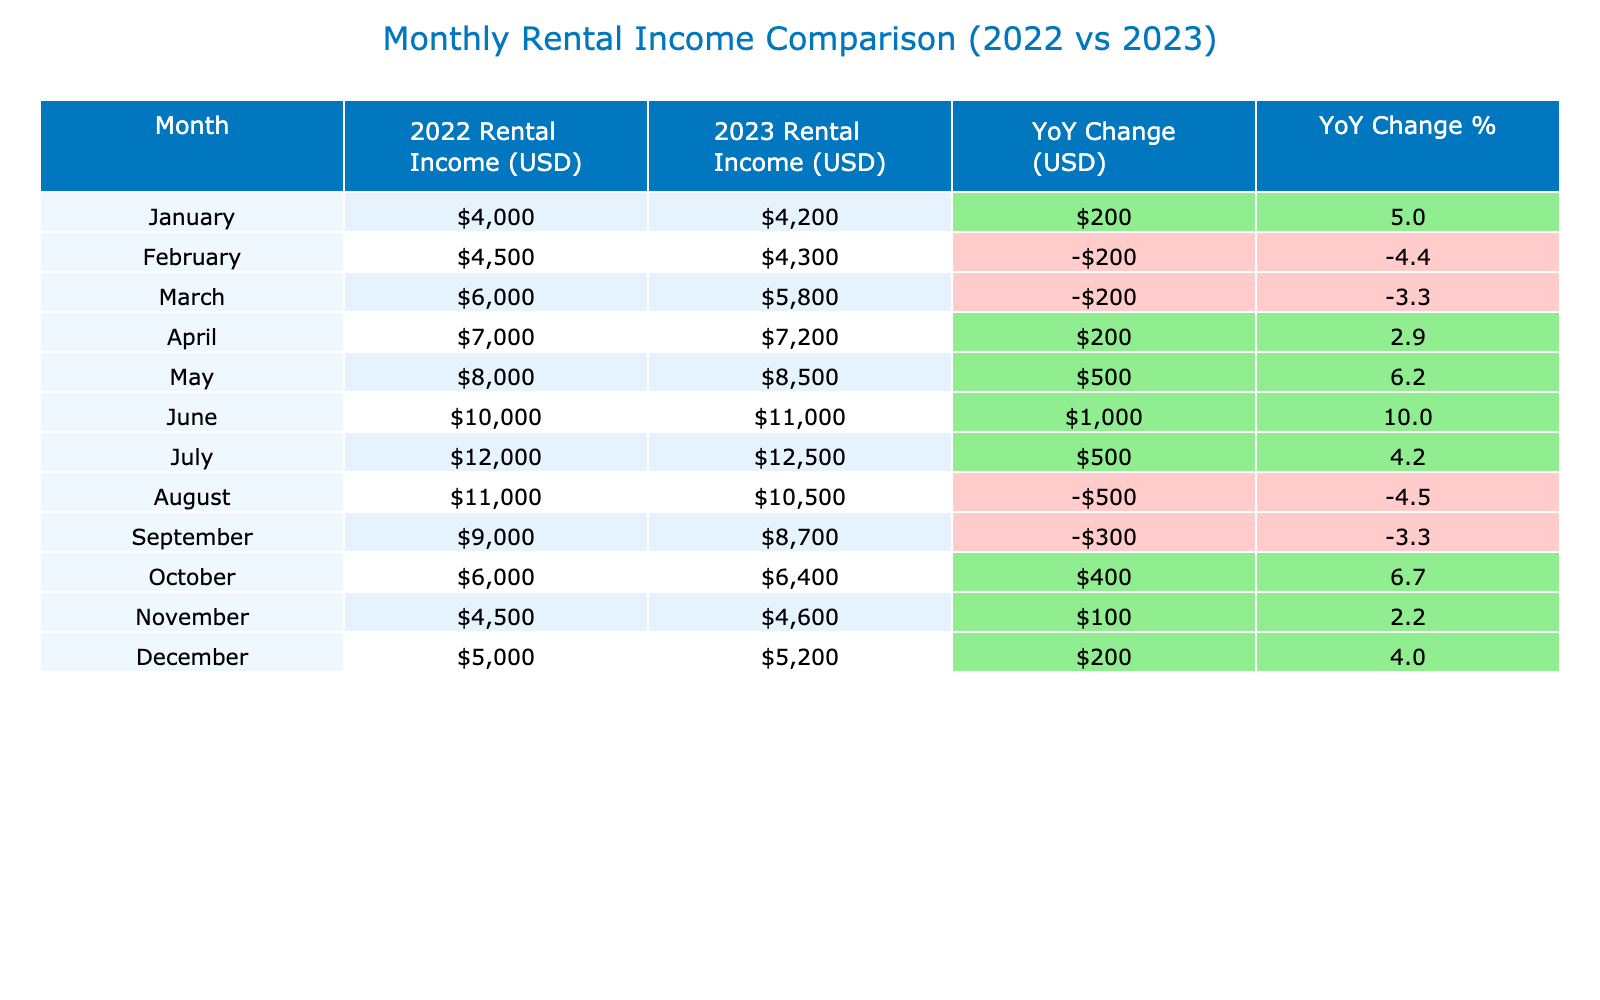What was the rental income for June 2022? By referring to the "2022 Rental Income (USD)" column for June, the value is directly listed as 10000.
Answer: 10000 What is the YoY Change for October? For October, the 2023 Rental Income is 6400 and the 2022 Rental Income is 6000. We calculate the YoY Change as 6400 - 6000 = 400.
Answer: 400 Was the rental income in December 2023 higher than in December 2022? In December 2022, the rental income was 5000, and in December 2023, it was 5200. Since 5200 is greater than 5000, the statement is true.
Answer: Yes What is the total rental income for all months in 2022? To find the total, we sum the 2022 rental income values: 4000 + 4500 + 6000 + 7000 + 8000 + 10000 + 12000 + 11000 + 9000 + 6000 + 4500 + 5000 = 86000.
Answer: 86000 Which month had the highest YoY Change in income? The YoY Change can be calculated for each month, and by examining them, we find that June had the highest YoY Change of 1000.
Answer: June What was the average rental income for the year 2023? The rental incomes for 2023 are: 4200, 4300, 5800, 7200, 8500, 11000, 12500, 10500, 8700, 6400, 4600, 5200. Adding these values gives a total of 69700, and dividing by 12 (the number of months) yields an average of approximately 5816.7.
Answer: 5816.7 Was there a decrease in rental income from August 2022 to August 2023? The rental income for August 2022 was 11000 and for August 2023 was 10500. Since 10500 is less than 11000, there was a decrease.
Answer: Yes What is the total YoY Change for the year 2023? To find the total YoY Change, we sum the monthly changes: 200 + -200 + -200 + 200 + 500 + 1000 + 500 + -600 + -300 + 400 + 100 + 200 = 300.
Answer: 300 Which month had the lowest rental income in 2022? In the "2022 Rental Income (USD)" column, January has the lowest value of 4000, which is the smallest amount for that year.
Answer: January What was the rental income difference between May 2022 and May 2023? The rental income for May 2022 was 8000 and for May 2023 was 8500. The difference is calculated as 8500 - 8000 = 500.
Answer: 500 